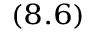Convert formula to latex. <formula><loc_0><loc_0><loc_500><loc_500>_ { ( 8 . 6 ) }</formula> 